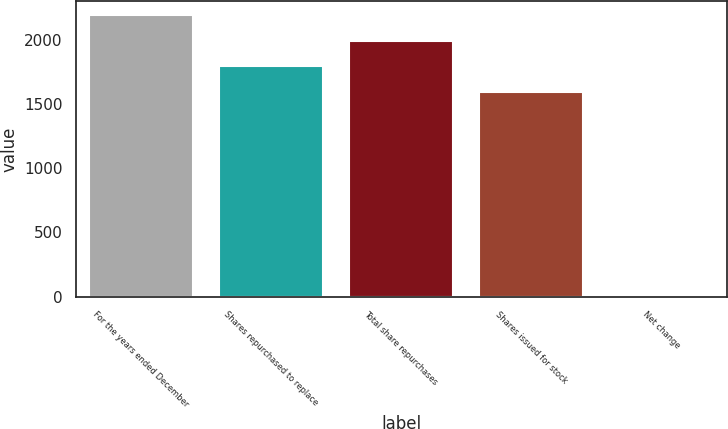Convert chart to OTSL. <chart><loc_0><loc_0><loc_500><loc_500><bar_chart><fcel>For the years ended December<fcel>Shares repurchased to replace<fcel>Total share repurchases<fcel>Shares issued for stock<fcel>Net change<nl><fcel>2192.9<fcel>1794.3<fcel>1993.6<fcel>1595<fcel>15<nl></chart> 